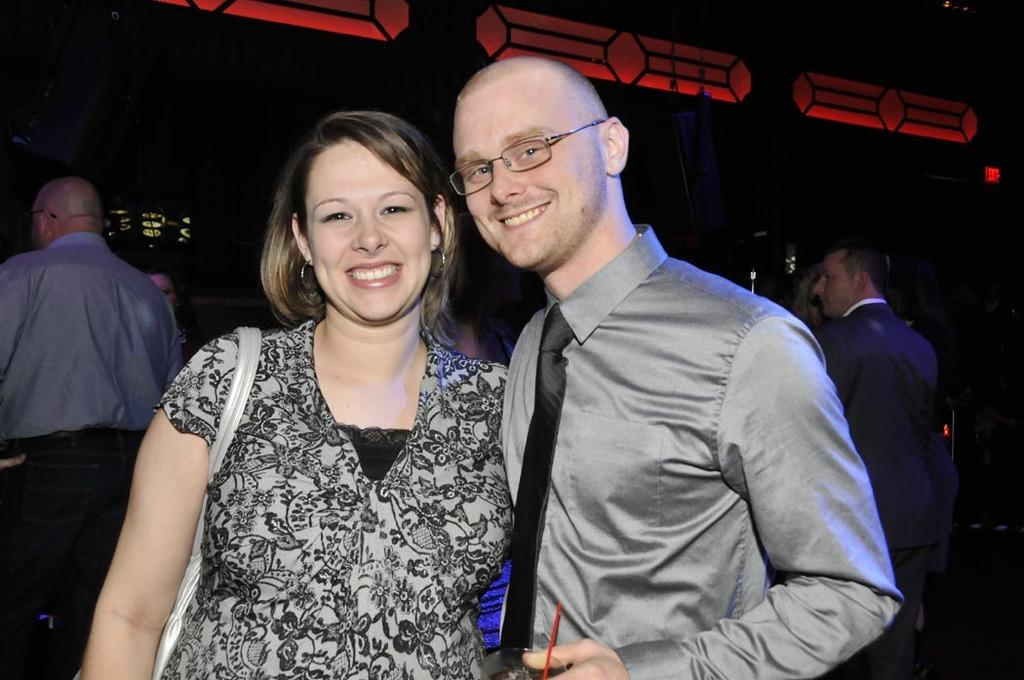How many persons are visible in the image? There are persons in the image. What else can be seen in the image besides the persons? There are other objects in the image. Can you describe the background of the image? There are persons, lights, and other objects in the background of the image. What type of bucket is being used to show respect in the image? There is no bucket or indication of respect shown in the image. 